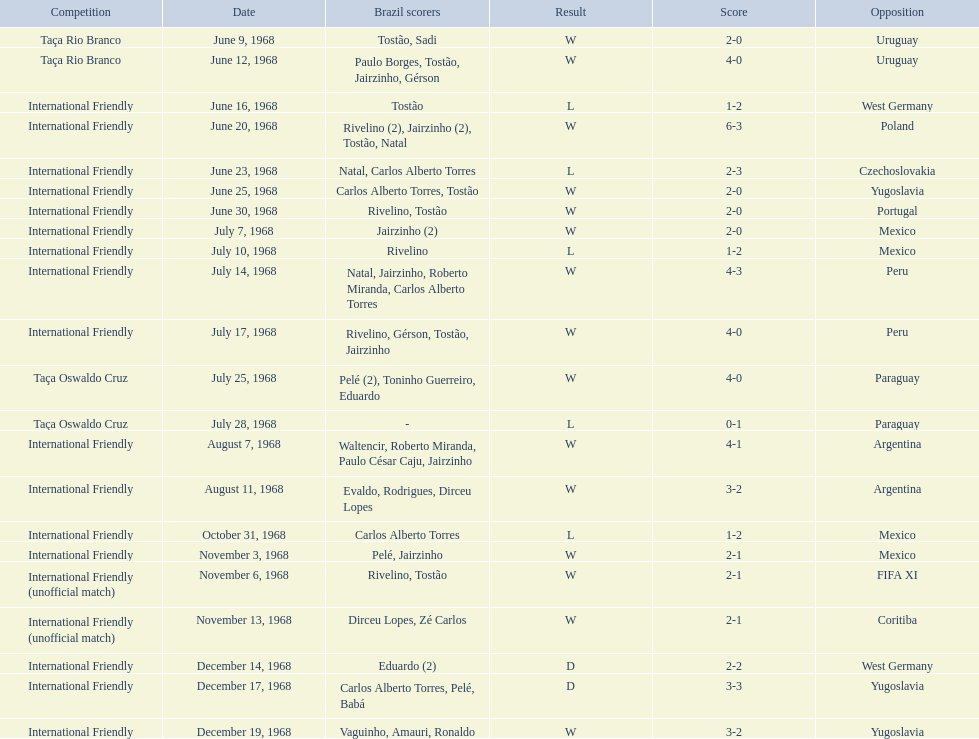Number of losses 5. I'm looking to parse the entire table for insights. Could you assist me with that? {'header': ['Competition', 'Date', 'Brazil scorers', 'Result', 'Score', 'Opposition'], 'rows': [['Taça Rio Branco', 'June 9, 1968', 'Tostão, Sadi', 'W', '2-0', 'Uruguay'], ['Taça Rio Branco', 'June 12, 1968', 'Paulo Borges, Tostão, Jairzinho, Gérson', 'W', '4-0', 'Uruguay'], ['International Friendly', 'June 16, 1968', 'Tostão', 'L', '1-2', 'West Germany'], ['International Friendly', 'June 20, 1968', 'Rivelino (2), Jairzinho (2), Tostão, Natal', 'W', '6-3', 'Poland'], ['International Friendly', 'June 23, 1968', 'Natal, Carlos Alberto Torres', 'L', '2-3', 'Czechoslovakia'], ['International Friendly', 'June 25, 1968', 'Carlos Alberto Torres, Tostão', 'W', '2-0', 'Yugoslavia'], ['International Friendly', 'June 30, 1968', 'Rivelino, Tostão', 'W', '2-0', 'Portugal'], ['International Friendly', 'July 7, 1968', 'Jairzinho (2)', 'W', '2-0', 'Mexico'], ['International Friendly', 'July 10, 1968', 'Rivelino', 'L', '1-2', 'Mexico'], ['International Friendly', 'July 14, 1968', 'Natal, Jairzinho, Roberto Miranda, Carlos Alberto Torres', 'W', '4-3', 'Peru'], ['International Friendly', 'July 17, 1968', 'Rivelino, Gérson, Tostão, Jairzinho', 'W', '4-0', 'Peru'], ['Taça Oswaldo Cruz', 'July 25, 1968', 'Pelé (2), Toninho Guerreiro, Eduardo', 'W', '4-0', 'Paraguay'], ['Taça Oswaldo Cruz', 'July 28, 1968', '-', 'L', '0-1', 'Paraguay'], ['International Friendly', 'August 7, 1968', 'Waltencir, Roberto Miranda, Paulo César Caju, Jairzinho', 'W', '4-1', 'Argentina'], ['International Friendly', 'August 11, 1968', 'Evaldo, Rodrigues, Dirceu Lopes', 'W', '3-2', 'Argentina'], ['International Friendly', 'October 31, 1968', 'Carlos Alberto Torres', 'L', '1-2', 'Mexico'], ['International Friendly', 'November 3, 1968', 'Pelé, Jairzinho', 'W', '2-1', 'Mexico'], ['International Friendly (unofficial match)', 'November 6, 1968', 'Rivelino, Tostão', 'W', '2-1', 'FIFA XI'], ['International Friendly (unofficial match)', 'November 13, 1968', 'Dirceu Lopes, Zé Carlos', 'W', '2-1', 'Coritiba'], ['International Friendly', 'December 14, 1968', 'Eduardo (2)', 'D', '2-2', 'West Germany'], ['International Friendly', 'December 17, 1968', 'Carlos Alberto Torres, Pelé, Babá', 'D', '3-3', 'Yugoslavia'], ['International Friendly', 'December 19, 1968', 'Vaguinho, Amauri, Ronaldo', 'W', '3-2', 'Yugoslavia']]} 